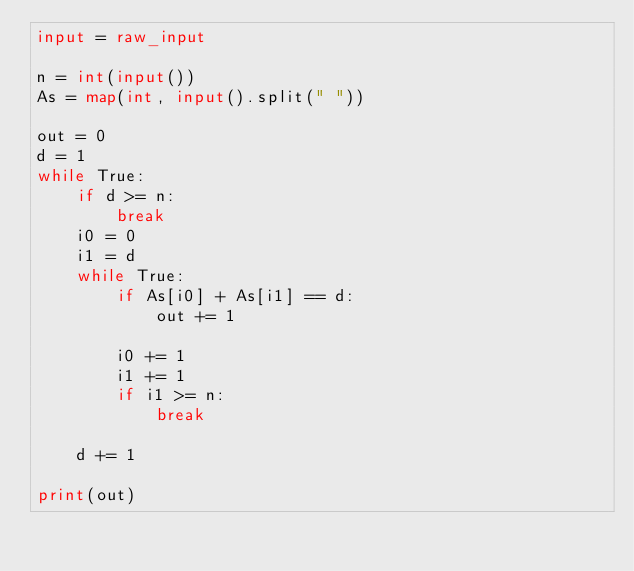<code> <loc_0><loc_0><loc_500><loc_500><_Python_>input = raw_input

n = int(input())
As = map(int, input().split(" "))

out = 0
d = 1
while True:
    if d >= n:
        break
    i0 = 0
    i1 = d
    while True:
        if As[i0] + As[i1] == d:
            out += 1

        i0 += 1 
        i1 += 1 
        if i1 >= n:
            break
    
    d += 1

print(out)</code> 